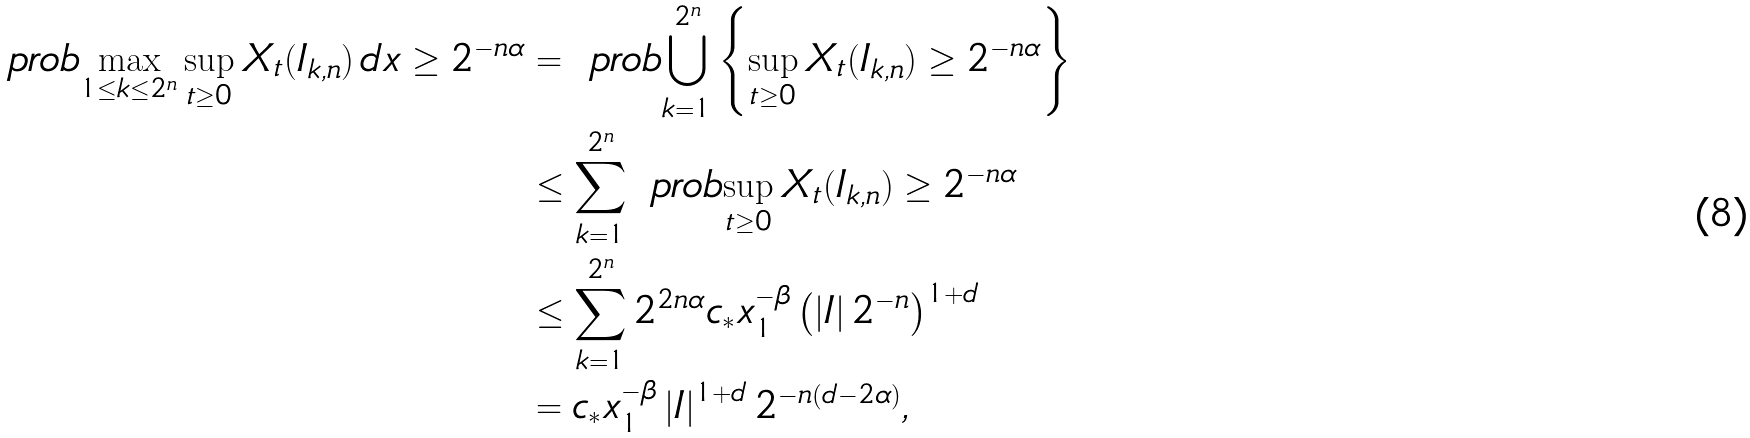Convert formula to latex. <formula><loc_0><loc_0><loc_500><loc_500>\ p r o b { \max _ { 1 \leq k \leq 2 ^ { n } } \sup _ { t \geq 0 } X _ { t } ( I _ { k , n } ) \, d x \geq 2 ^ { - n \alpha } } & = \ p r o b { \bigcup _ { k = 1 } ^ { 2 ^ { n } } \left \{ \sup _ { t \geq 0 } X _ { t } ( I _ { k , n } ) \geq 2 ^ { - n \alpha } \right \} } \\ & \leq \sum _ { k = 1 } ^ { 2 ^ { n } } \ p r o b { \sup _ { t \geq 0 } X _ { t } ( I _ { k , n } ) \geq 2 ^ { - n \alpha } } \\ & \leq \sum _ { k = 1 } ^ { 2 ^ { n } } 2 ^ { 2 n \alpha } c _ { * } x _ { 1 } ^ { - \beta } \left ( \left | I \right | 2 ^ { - n } \right ) ^ { 1 + d } \\ & = c _ { * } x _ { 1 } ^ { - \beta } \left | I \right | ^ { 1 + d } 2 ^ { - n ( d - 2 \alpha ) } ,</formula> 